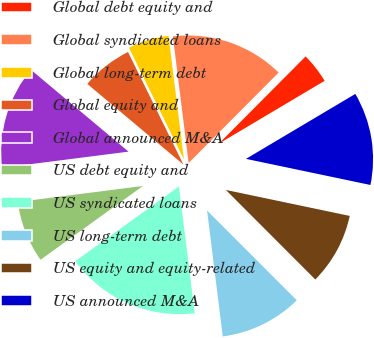Convert chart to OTSL. <chart><loc_0><loc_0><loc_500><loc_500><pie_chart><fcel>Global debt equity and<fcel>Global syndicated loans<fcel>Global long-term debt<fcel>Global equity and<fcel>Global announced M&A<fcel>US debt equity and<fcel>US syndicated loans<fcel>US long-term debt<fcel>US equity and equity-related<fcel>US announced M&A<nl><fcel>4.01%<fcel>14.43%<fcel>5.31%<fcel>6.61%<fcel>13.13%<fcel>7.92%<fcel>17.03%<fcel>10.52%<fcel>9.22%<fcel>11.82%<nl></chart> 